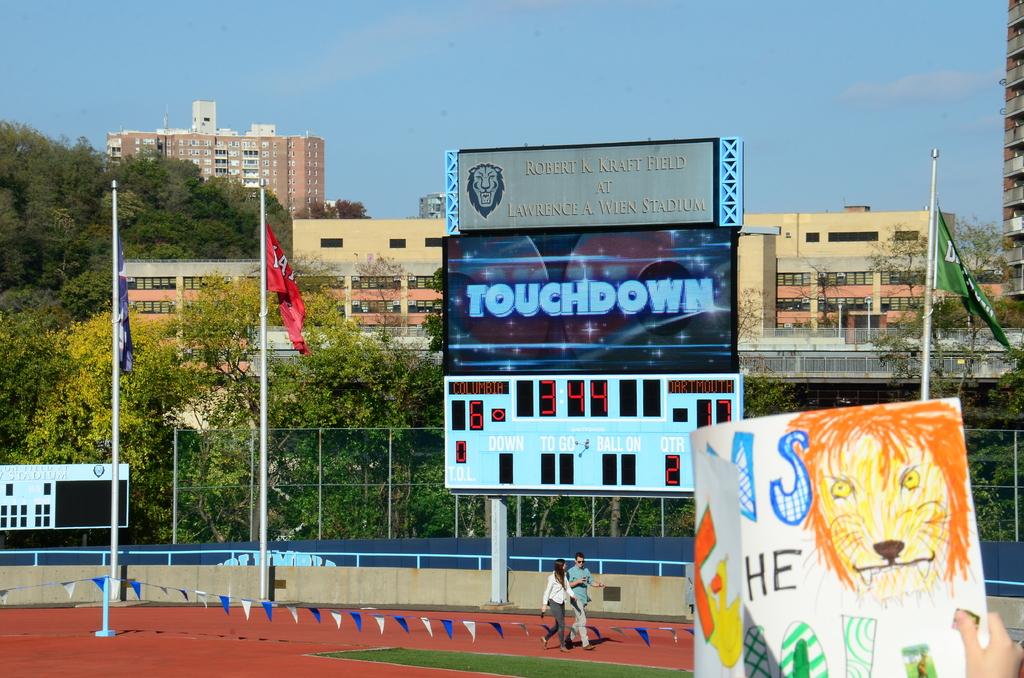What is on the board in large font?
Ensure brevity in your answer.  Touchdown. 